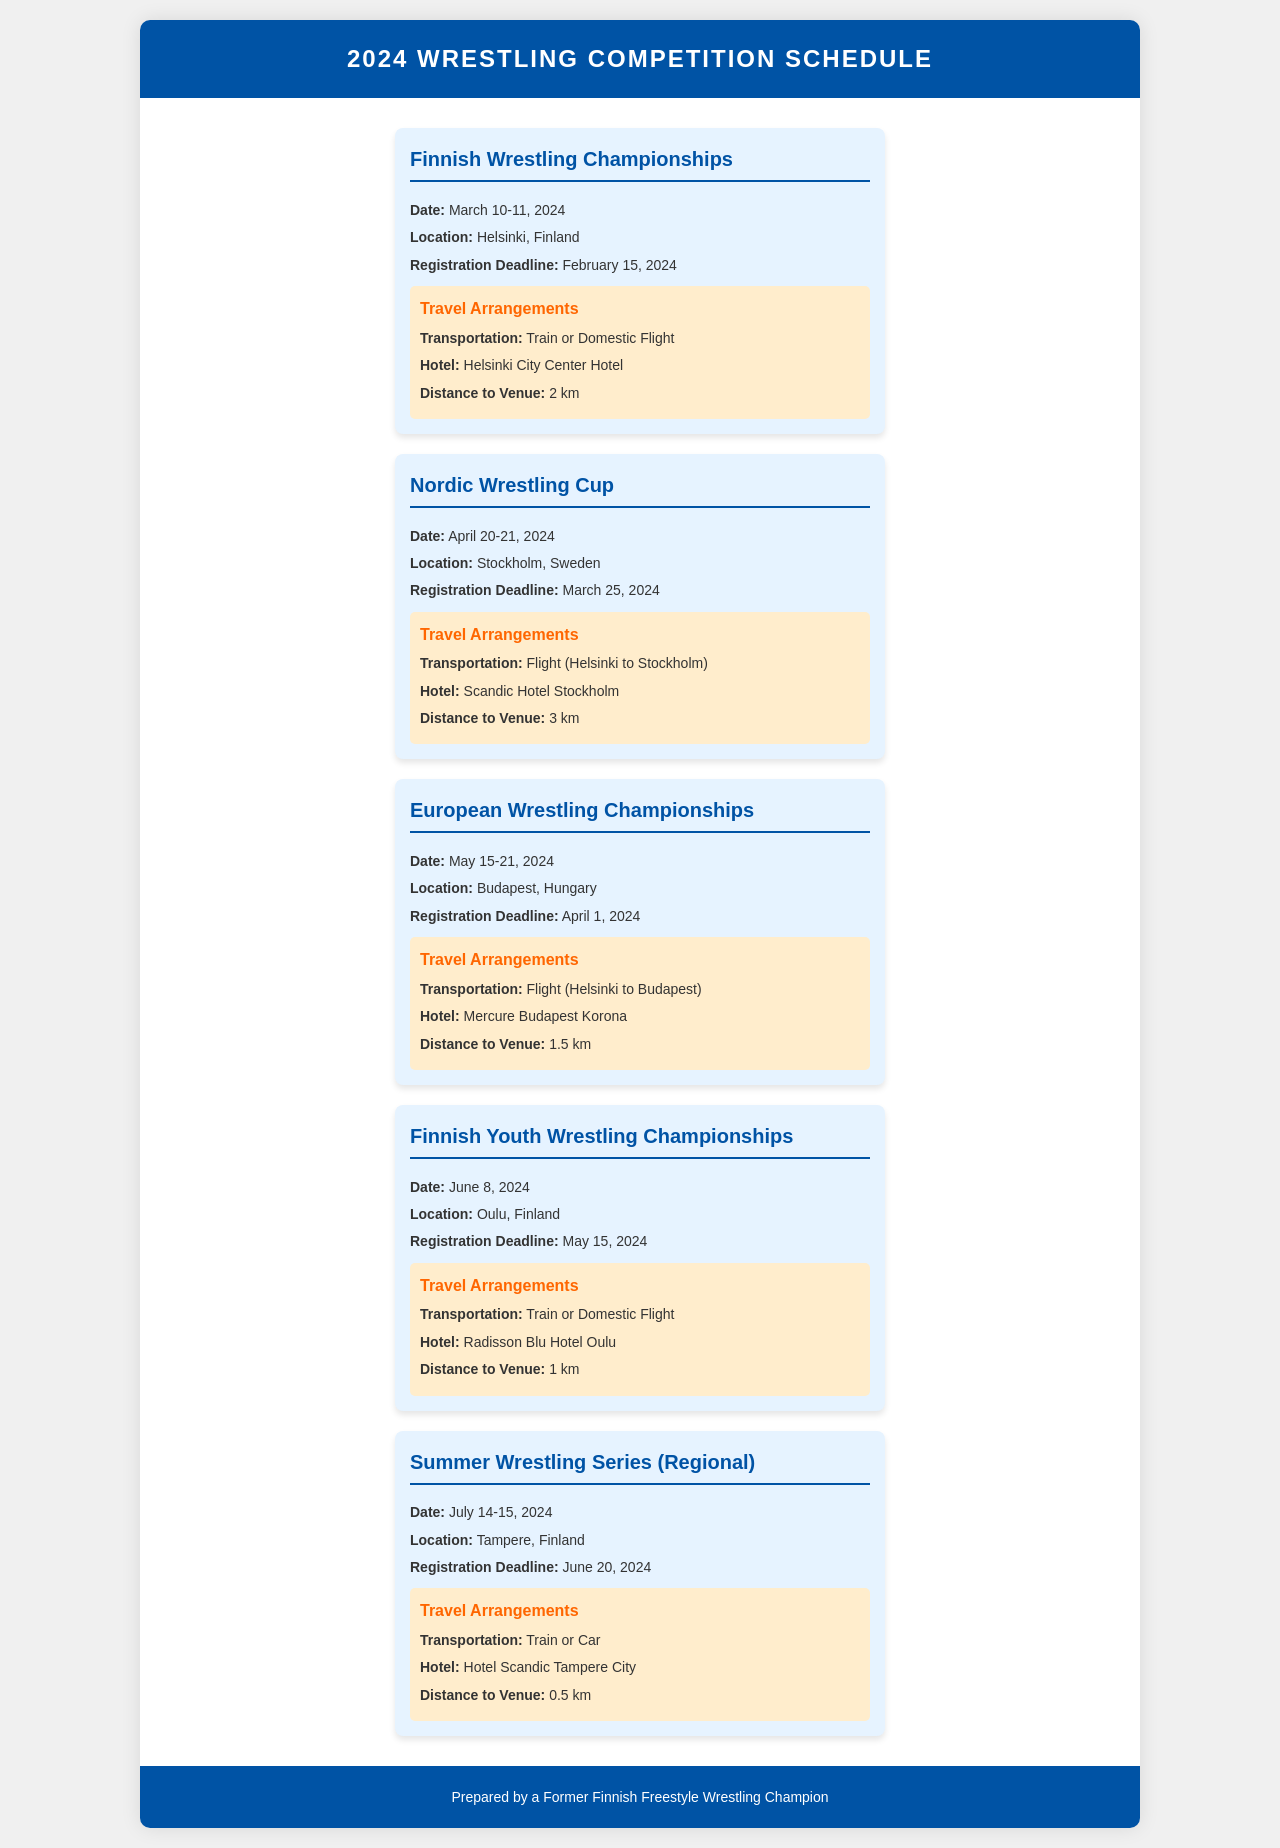What is the date of the Finnish Wrestling Championships? The date of the Finnish Wrestling Championships is specified in the document.
Answer: March 10-11, 2024 What is the registration deadline for the Nordic Wrestling Cup? The registration deadline can be found under the Nordic Wrestling Cup event details.
Answer: March 25, 2024 Where is the European Wrestling Championships held? The location of the European Wrestling Championships is clearly mentioned in the event details.
Answer: Budapest, Hungary What type of transportation is available for the Finnish Youth Wrestling Championships? The document lists transportation options for each event, and for the Finnish Youth Wrestling Championships, it's specified.
Answer: Train or Domestic Flight How far is the Scandic Hotel Stockholm from the Nordic Wrestling Cup venue? The distance to the venue for the Nordic Wrestling Cup is provided in the travel arrangements section.
Answer: 3 km What is the date of the Summer Wrestling Series? The date of the Summer Wrestling Series is mentioned in the event title and details.
Answer: July 14-15, 2024 What hotel is suggested for the Finnish Wrestling Championships? The hotel information is included in the travel arrangements for each event.
Answer: Helsinki City Center Hotel Which event occurs closest to May 15, 2024? By comparing the dates provided for the events, you can determine which is nearest to May 15, 2024.
Answer: Finnish Youth Wrestling Championships What is the maximum distance to venue from any hotel listed in the document? The distances to each venue are specified, and by comparing them, we find the maximum.
Answer: 3 km 